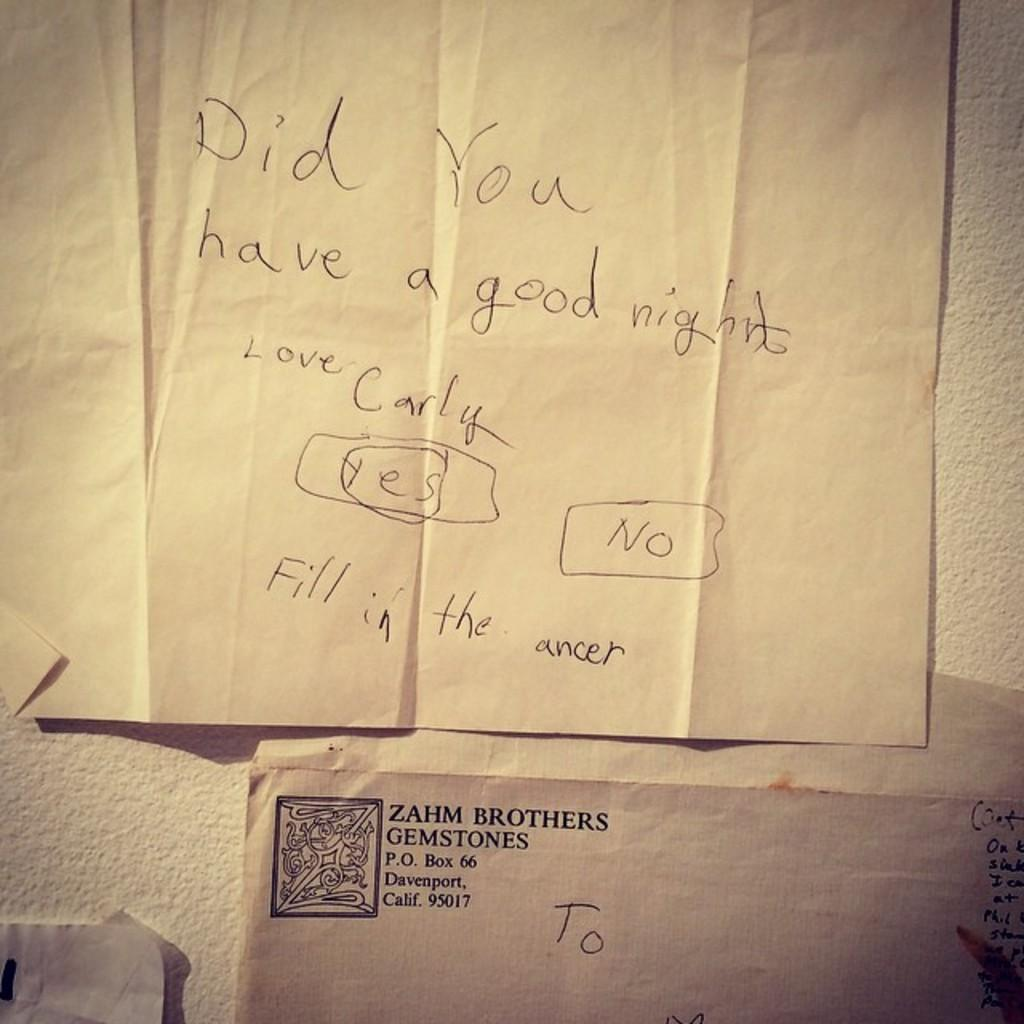<image>
Write a terse but informative summary of the picture. A letter written on a piece of paper asking if someone had a good night. 